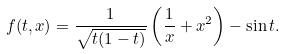Convert formula to latex. <formula><loc_0><loc_0><loc_500><loc_500>f ( t , x ) = \frac { 1 } { \sqrt { t ( 1 - t ) } } \left ( \frac { 1 } { x } + x ^ { 2 } \right ) - \sin t .</formula> 